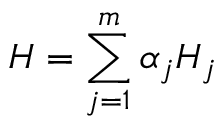<formula> <loc_0><loc_0><loc_500><loc_500>H = \sum _ { j = 1 } ^ { m } \alpha _ { j } H _ { j }</formula> 